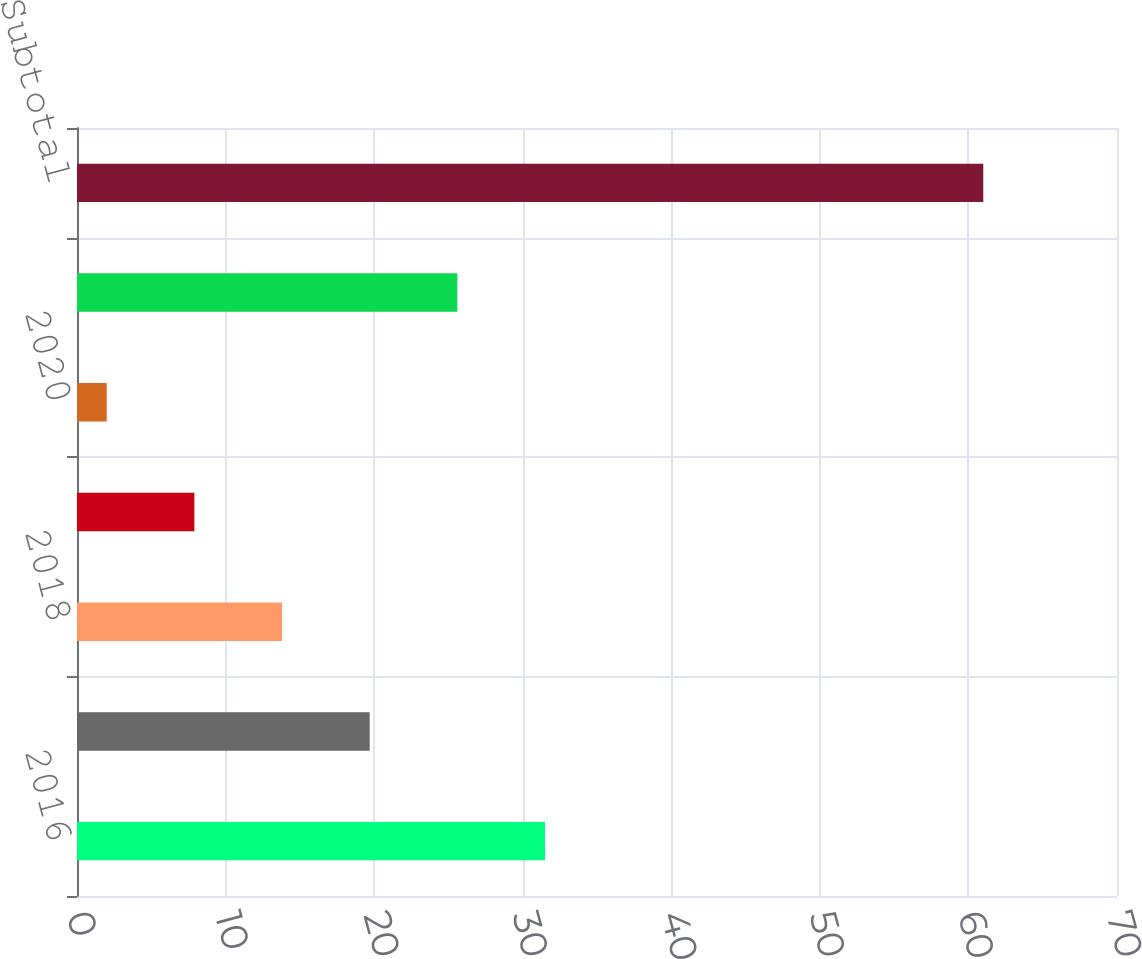Convert chart. <chart><loc_0><loc_0><loc_500><loc_500><bar_chart><fcel>2016<fcel>2017<fcel>2018<fcel>2019<fcel>2020<fcel>Thereafter<fcel>Subtotal<nl><fcel>31.5<fcel>19.7<fcel>13.8<fcel>7.9<fcel>2<fcel>25.6<fcel>61<nl></chart> 